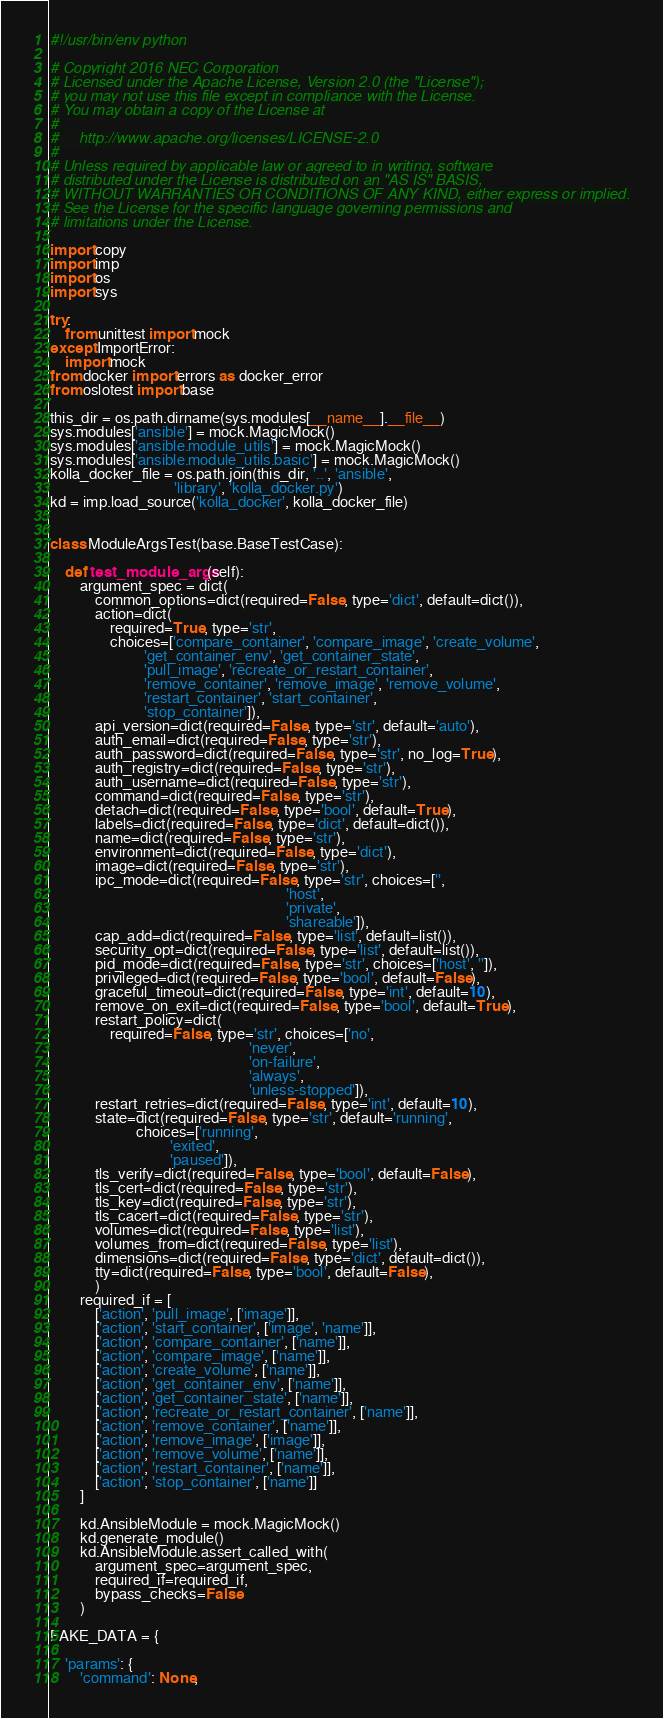Convert code to text. <code><loc_0><loc_0><loc_500><loc_500><_Python_>#!/usr/bin/env python

# Copyright 2016 NEC Corporation
# Licensed under the Apache License, Version 2.0 (the "License");
# you may not use this file except in compliance with the License.
# You may obtain a copy of the License at
#
#     http://www.apache.org/licenses/LICENSE-2.0
#
# Unless required by applicable law or agreed to in writing, software
# distributed under the License is distributed on an "AS IS" BASIS,
# WITHOUT WARRANTIES OR CONDITIONS OF ANY KIND, either express or implied.
# See the License for the specific language governing permissions and
# limitations under the License.

import copy
import imp
import os
import sys

try:
    from unittest import mock
except ImportError:
    import mock
from docker import errors as docker_error
from oslotest import base

this_dir = os.path.dirname(sys.modules[__name__].__file__)
sys.modules['ansible'] = mock.MagicMock()
sys.modules['ansible.module_utils'] = mock.MagicMock()
sys.modules['ansible.module_utils.basic'] = mock.MagicMock()
kolla_docker_file = os.path.join(this_dir, '..', 'ansible',
                                 'library', 'kolla_docker.py')
kd = imp.load_source('kolla_docker', kolla_docker_file)


class ModuleArgsTest(base.BaseTestCase):

    def test_module_args(self):
        argument_spec = dict(
            common_options=dict(required=False, type='dict', default=dict()),
            action=dict(
                required=True, type='str',
                choices=['compare_container', 'compare_image', 'create_volume',
                         'get_container_env', 'get_container_state',
                         'pull_image', 'recreate_or_restart_container',
                         'remove_container', 'remove_image', 'remove_volume',
                         'restart_container', 'start_container',
                         'stop_container']),
            api_version=dict(required=False, type='str', default='auto'),
            auth_email=dict(required=False, type='str'),
            auth_password=dict(required=False, type='str', no_log=True),
            auth_registry=dict(required=False, type='str'),
            auth_username=dict(required=False, type='str'),
            command=dict(required=False, type='str'),
            detach=dict(required=False, type='bool', default=True),
            labels=dict(required=False, type='dict', default=dict()),
            name=dict(required=False, type='str'),
            environment=dict(required=False, type='dict'),
            image=dict(required=False, type='str'),
            ipc_mode=dict(required=False, type='str', choices=['',
                                                               'host',
                                                               'private',
                                                               'shareable']),
            cap_add=dict(required=False, type='list', default=list()),
            security_opt=dict(required=False, type='list', default=list()),
            pid_mode=dict(required=False, type='str', choices=['host', '']),
            privileged=dict(required=False, type='bool', default=False),
            graceful_timeout=dict(required=False, type='int', default=10),
            remove_on_exit=dict(required=False, type='bool', default=True),
            restart_policy=dict(
                required=False, type='str', choices=['no',
                                                     'never',
                                                     'on-failure',
                                                     'always',
                                                     'unless-stopped']),
            restart_retries=dict(required=False, type='int', default=10),
            state=dict(required=False, type='str', default='running',
                       choices=['running',
                                'exited',
                                'paused']),
            tls_verify=dict(required=False, type='bool', default=False),
            tls_cert=dict(required=False, type='str'),
            tls_key=dict(required=False, type='str'),
            tls_cacert=dict(required=False, type='str'),
            volumes=dict(required=False, type='list'),
            volumes_from=dict(required=False, type='list'),
            dimensions=dict(required=False, type='dict', default=dict()),
            tty=dict(required=False, type='bool', default=False),
            )
        required_if = [
            ['action', 'pull_image', ['image']],
            ['action', 'start_container', ['image', 'name']],
            ['action', 'compare_container', ['name']],
            ['action', 'compare_image', ['name']],
            ['action', 'create_volume', ['name']],
            ['action', 'get_container_env', ['name']],
            ['action', 'get_container_state', ['name']],
            ['action', 'recreate_or_restart_container', ['name']],
            ['action', 'remove_container', ['name']],
            ['action', 'remove_image', ['image']],
            ['action', 'remove_volume', ['name']],
            ['action', 'restart_container', ['name']],
            ['action', 'stop_container', ['name']]
        ]

        kd.AnsibleModule = mock.MagicMock()
        kd.generate_module()
        kd.AnsibleModule.assert_called_with(
            argument_spec=argument_spec,
            required_if=required_if,
            bypass_checks=False
        )

FAKE_DATA = {

    'params': {
        'command': None,</code> 